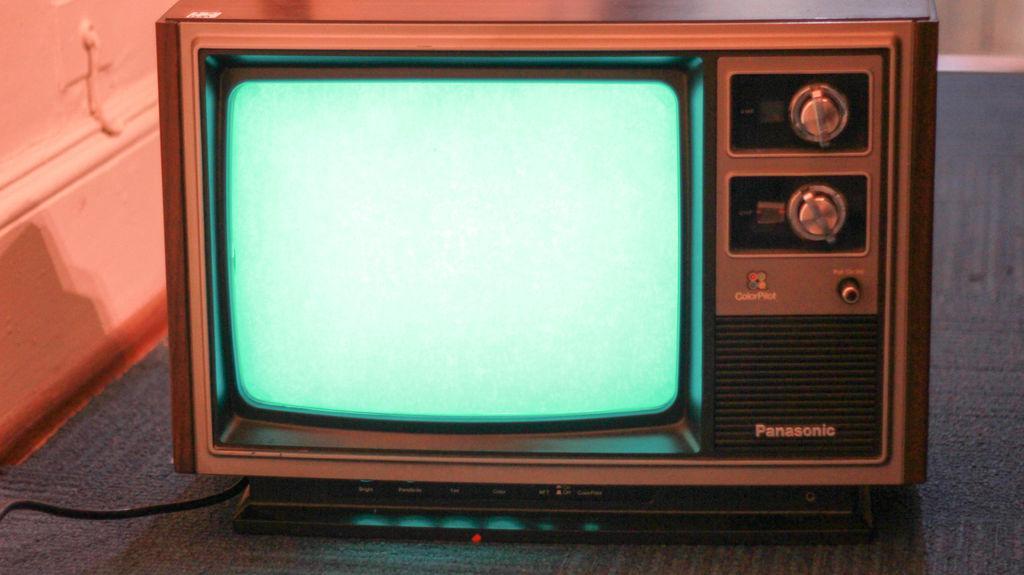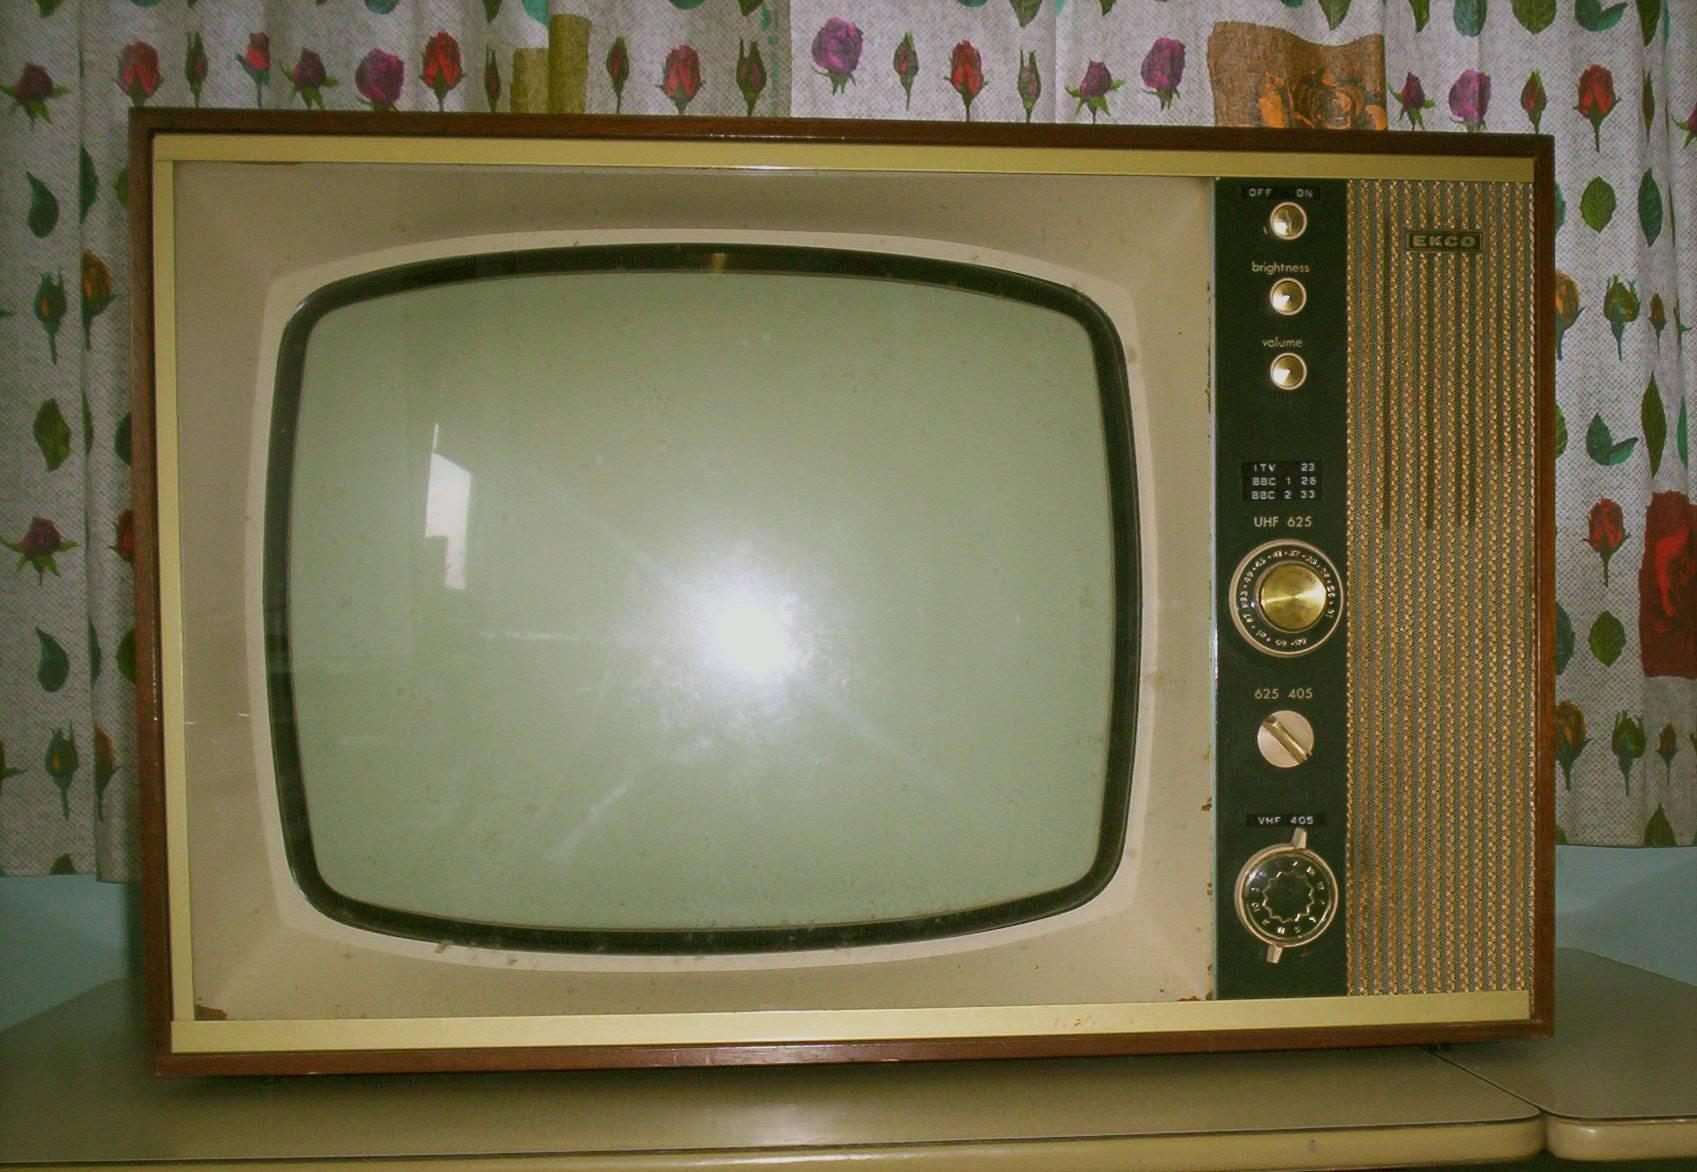The first image is the image on the left, the second image is the image on the right. Considering the images on both sides, is "A portable television has a vertical control area to one side, with two large knobs at the top, and a small speaker area below." valid? Answer yes or no. Yes. The first image is the image on the left, the second image is the image on the right. Assess this claim about the two images: "A frame is mounted to a wall in the image on the left.". Correct or not? Answer yes or no. No. The first image is the image on the left, the second image is the image on the right. For the images shown, is this caption "The screen on one of the old-fashioned TVs is glowing, showing the set is turned on." true? Answer yes or no. Yes. The first image is the image on the left, the second image is the image on the right. Considering the images on both sides, is "There are at least two round knobs on each television." valid? Answer yes or no. Yes. 